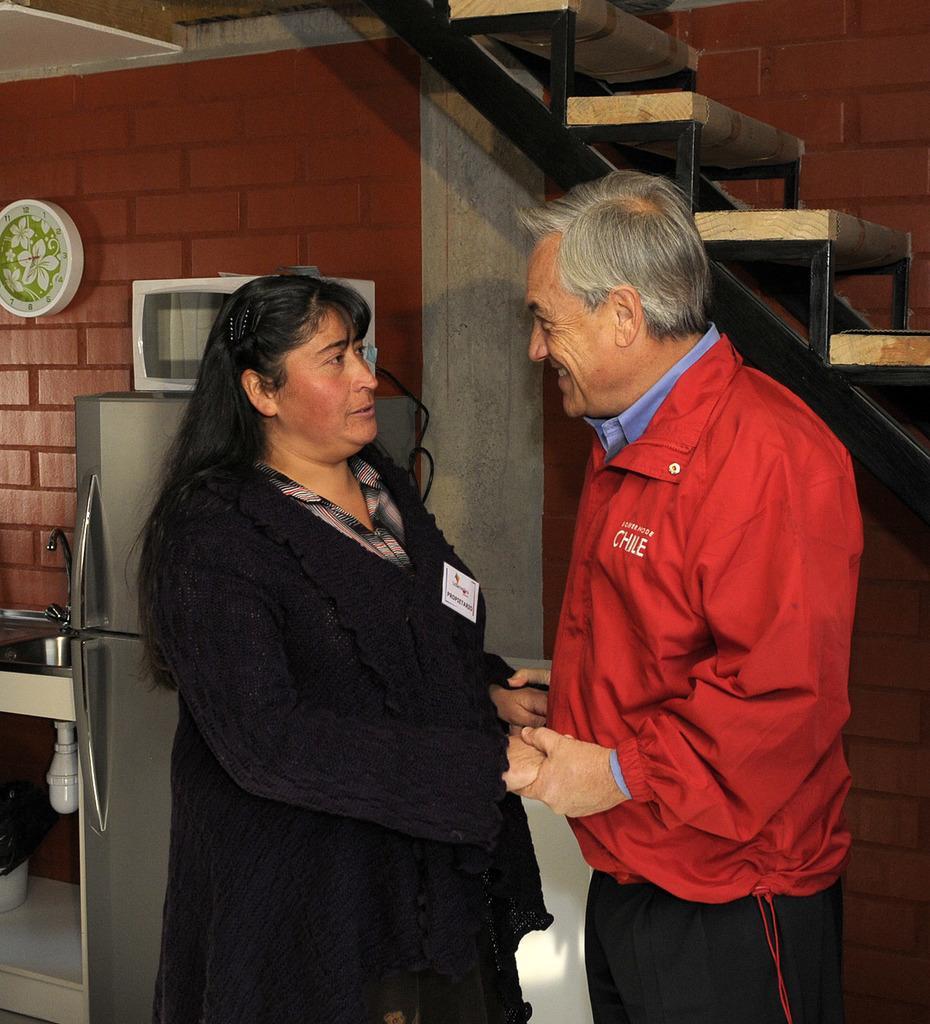Please provide a concise description of this image. These two people are looking at each-other and holding there hands. A clock is on the wall. Above the fridge there is an oven. Beside these people we can see stairs. Beside this fridge we can see sink with pipe and tap. Under the sink there is a bin.  